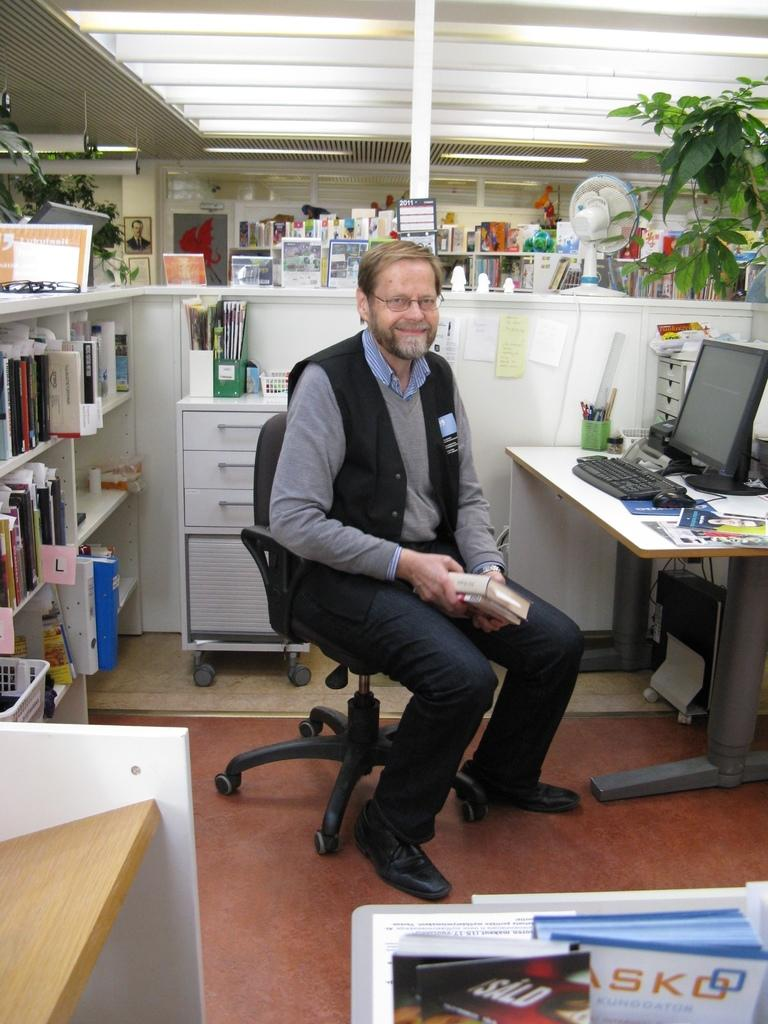Provide a one-sentence caption for the provided image. A man sits in his office in front of an alphabetized shelf of materials. 